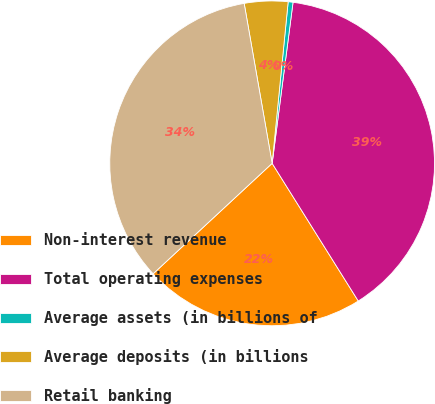Convert chart to OTSL. <chart><loc_0><loc_0><loc_500><loc_500><pie_chart><fcel>Non-interest revenue<fcel>Total operating expenses<fcel>Average assets (in billions of<fcel>Average deposits (in billions<fcel>Retail banking<nl><fcel>21.99%<fcel>39.05%<fcel>0.48%<fcel>4.33%<fcel>34.15%<nl></chart> 